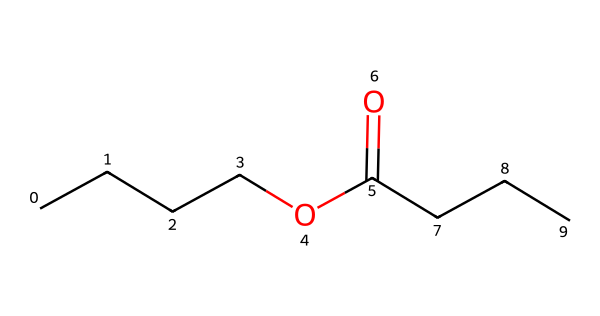What is the total number of carbon atoms in butyl butyrate? In the SMILES representation "CCCCOC(=O)CCC", the portion "CCCC" indicates a straight-chain of 4 carbon atoms, and the "CCC" after the carbonyl indicates another chain of 3 carbon atoms. Adding these gives a total of 4 + 3 = 7 carbon atoms.
Answer: 7 How many oxygen atoms are present in butyl butyrate? The SMILES representation includes "O" before the carbonyl "C(=O)" and "OC" indicating an ester function, which shows that there are 2 oxygen atoms in total.
Answer: 2 What functional group is indicated by "C(=O)O" in the structure? The "C(=O)O" represents a carboxylate group part of the ester functional group; "C(=O)" indicates a carbonyl (C=O) bonded to an oxygen (O). Hence, this signifies the ester functional group is present.
Answer: ester What is the degree of unsaturation of butyl butyrate? The degree of unsaturation can be calculated based on the number of rings and double bonds in the structure. In butyl butyrate, there are no double bonds or rings evident in the SMILES. Therefore, the degree of unsaturation is 0.
Answer: 0 What type of smell or flavor is commonly associated with butyl butyrate? Butyl butyrate is typically associated with fruity aromas, specifically resembling the scent of pineapple or apple. This is often due to the ester structure which gives it sweet, fruity characteristics.
Answer: fruity What are the possible sources of butyl butyrate in nature? Butyl butyrate can be naturally found in the fermentation process of some fruits and is present in essential oils, particularly in foods like butter and various fruits. This makes it a common compound in flavoring agents.
Answer: fruits 